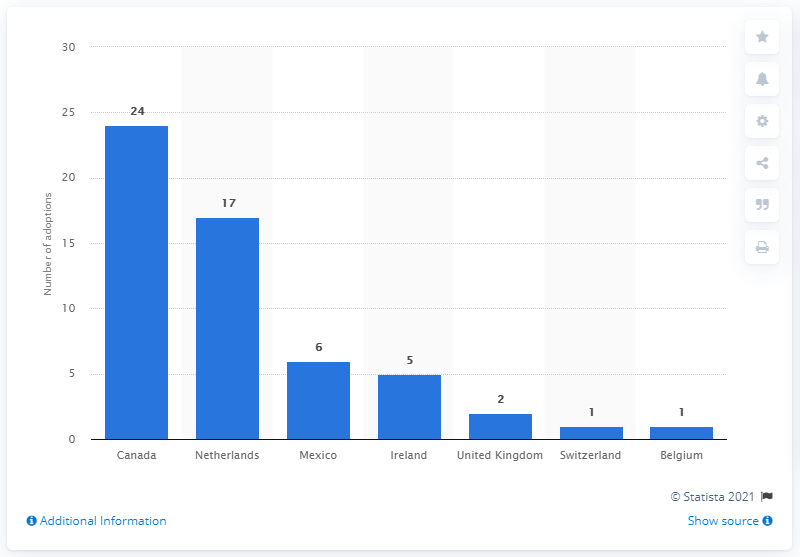Give some essential details in this illustration. In 2019, 24 children were adopted by families living in Canada. 